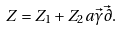Convert formula to latex. <formula><loc_0><loc_0><loc_500><loc_500>Z = Z _ { 1 } + Z _ { 2 } a \vec { \gamma } \vec { \partial } .</formula> 